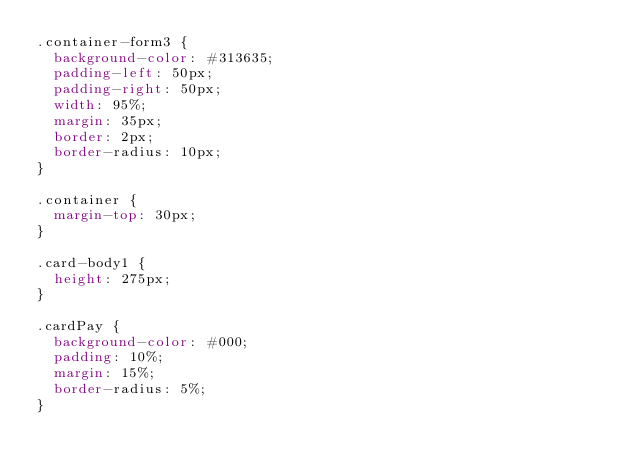Convert code to text. <code><loc_0><loc_0><loc_500><loc_500><_CSS_>.container-form3 {
  background-color: #313635;
  padding-left: 50px;
  padding-right: 50px;
  width: 95%;
  margin: 35px;
  border: 2px;
  border-radius: 10px;
}

.container {
  margin-top: 30px;
}

.card-body1 {
  height: 275px;
}

.cardPay {
  background-color: #000;
  padding: 10%;
  margin: 15%;
  border-radius: 5%;
}
</code> 